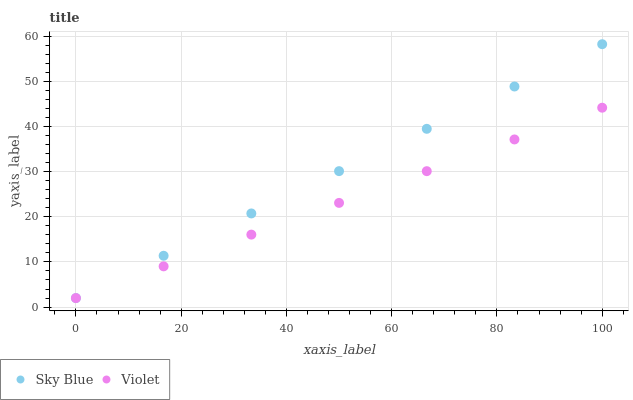Does Violet have the minimum area under the curve?
Answer yes or no. Yes. Does Sky Blue have the maximum area under the curve?
Answer yes or no. Yes. Does Violet have the maximum area under the curve?
Answer yes or no. No. Is Violet the smoothest?
Answer yes or no. Yes. Is Sky Blue the roughest?
Answer yes or no. Yes. Is Violet the roughest?
Answer yes or no. No. Does Sky Blue have the lowest value?
Answer yes or no. Yes. Does Sky Blue have the highest value?
Answer yes or no. Yes. Does Violet have the highest value?
Answer yes or no. No. Does Sky Blue intersect Violet?
Answer yes or no. Yes. Is Sky Blue less than Violet?
Answer yes or no. No. Is Sky Blue greater than Violet?
Answer yes or no. No. 